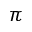Convert formula to latex. <formula><loc_0><loc_0><loc_500><loc_500>\pi</formula> 